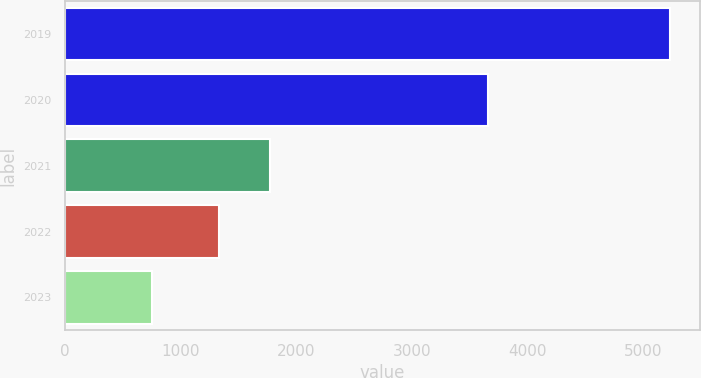Convert chart to OTSL. <chart><loc_0><loc_0><loc_500><loc_500><bar_chart><fcel>2019<fcel>2020<fcel>2021<fcel>2022<fcel>2023<nl><fcel>5227<fcel>3655<fcel>1775.8<fcel>1328<fcel>749<nl></chart> 